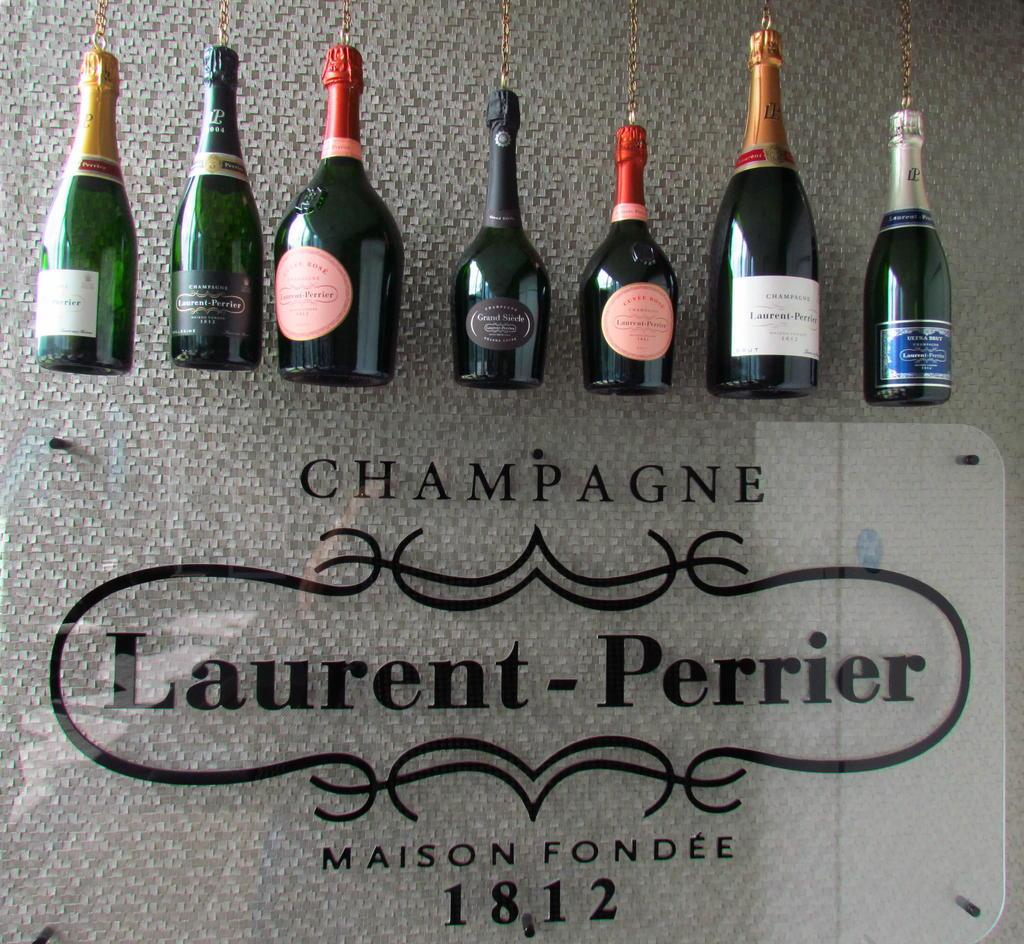<image>
Create a compact narrative representing the image presented. the word laurent is next to some champagne 